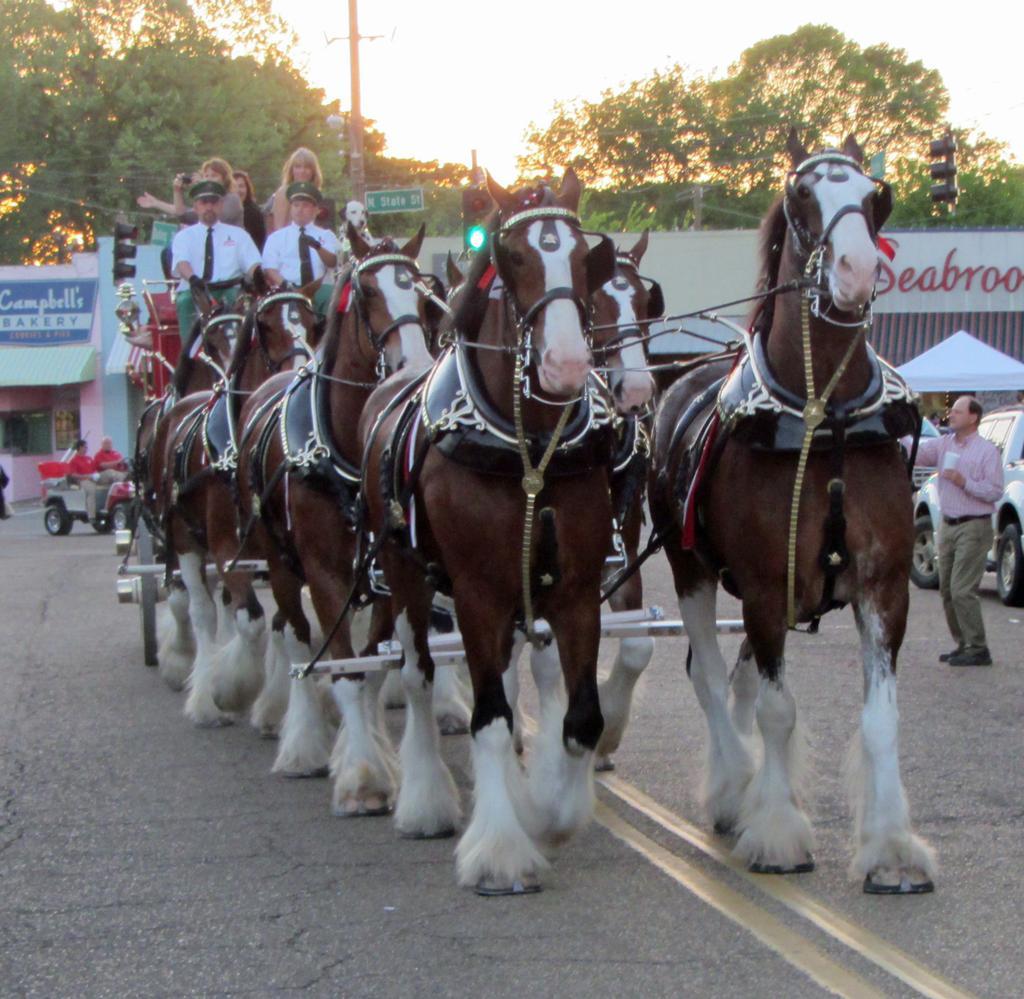Could you give a brief overview of what you see in this image? In this picture there are people and we can see horses, cart, vehicles on the road, pole, boards and stores. In the background of the image we can see trees and sky. 